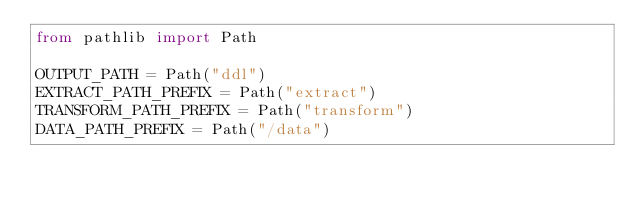Convert code to text. <code><loc_0><loc_0><loc_500><loc_500><_Python_>from pathlib import Path

OUTPUT_PATH = Path("ddl")
EXTRACT_PATH_PREFIX = Path("extract")
TRANSFORM_PATH_PREFIX = Path("transform")
DATA_PATH_PREFIX = Path("/data")
</code> 